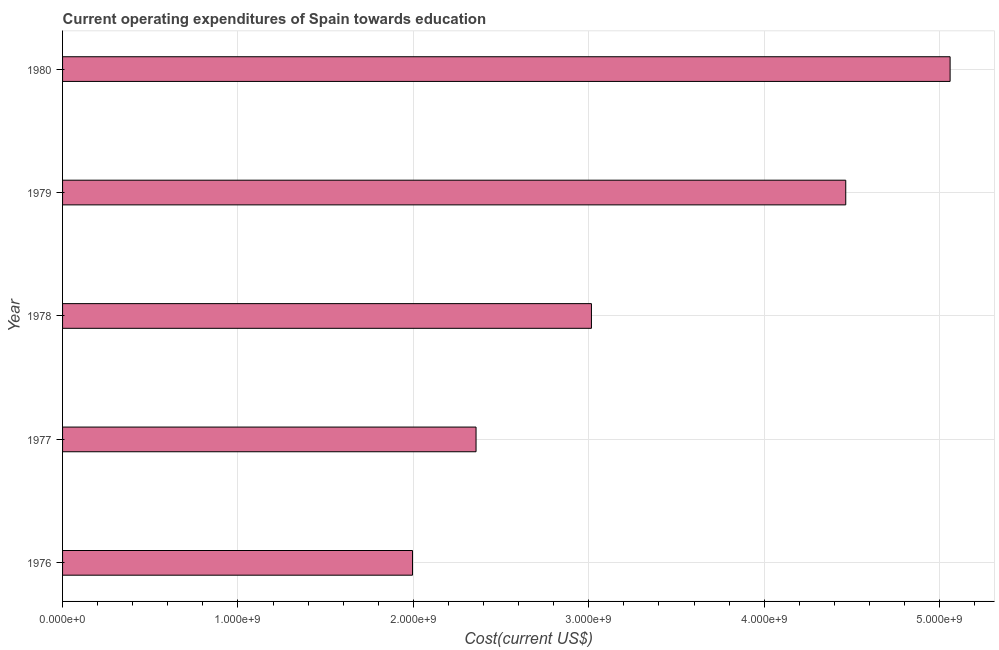Does the graph contain any zero values?
Ensure brevity in your answer.  No. Does the graph contain grids?
Give a very brief answer. Yes. What is the title of the graph?
Your answer should be very brief. Current operating expenditures of Spain towards education. What is the label or title of the X-axis?
Ensure brevity in your answer.  Cost(current US$). What is the label or title of the Y-axis?
Provide a succinct answer. Year. What is the education expenditure in 1977?
Make the answer very short. 2.36e+09. Across all years, what is the maximum education expenditure?
Give a very brief answer. 5.06e+09. Across all years, what is the minimum education expenditure?
Make the answer very short. 1.99e+09. In which year was the education expenditure maximum?
Your response must be concise. 1980. In which year was the education expenditure minimum?
Keep it short and to the point. 1976. What is the sum of the education expenditure?
Give a very brief answer. 1.69e+1. What is the difference between the education expenditure in 1978 and 1979?
Provide a short and direct response. -1.45e+09. What is the average education expenditure per year?
Your response must be concise. 3.38e+09. What is the median education expenditure?
Ensure brevity in your answer.  3.01e+09. Do a majority of the years between 1976 and 1979 (inclusive) have education expenditure greater than 3600000000 US$?
Make the answer very short. No. What is the ratio of the education expenditure in 1978 to that in 1980?
Provide a short and direct response. 0.6. Is the education expenditure in 1976 less than that in 1977?
Give a very brief answer. Yes. Is the difference between the education expenditure in 1976 and 1980 greater than the difference between any two years?
Your answer should be very brief. Yes. What is the difference between the highest and the second highest education expenditure?
Your answer should be very brief. 5.95e+08. What is the difference between the highest and the lowest education expenditure?
Keep it short and to the point. 3.06e+09. How many bars are there?
Your response must be concise. 5. Are all the bars in the graph horizontal?
Make the answer very short. Yes. How many years are there in the graph?
Your response must be concise. 5. What is the difference between two consecutive major ticks on the X-axis?
Provide a short and direct response. 1.00e+09. What is the Cost(current US$) of 1976?
Your response must be concise. 1.99e+09. What is the Cost(current US$) in 1977?
Offer a terse response. 2.36e+09. What is the Cost(current US$) of 1978?
Give a very brief answer. 3.01e+09. What is the Cost(current US$) of 1979?
Provide a short and direct response. 4.46e+09. What is the Cost(current US$) in 1980?
Provide a succinct answer. 5.06e+09. What is the difference between the Cost(current US$) in 1976 and 1977?
Provide a succinct answer. -3.62e+08. What is the difference between the Cost(current US$) in 1976 and 1978?
Offer a terse response. -1.02e+09. What is the difference between the Cost(current US$) in 1976 and 1979?
Your response must be concise. -2.47e+09. What is the difference between the Cost(current US$) in 1976 and 1980?
Give a very brief answer. -3.06e+09. What is the difference between the Cost(current US$) in 1977 and 1978?
Give a very brief answer. -6.58e+08. What is the difference between the Cost(current US$) in 1977 and 1979?
Make the answer very short. -2.11e+09. What is the difference between the Cost(current US$) in 1977 and 1980?
Give a very brief answer. -2.70e+09. What is the difference between the Cost(current US$) in 1978 and 1979?
Offer a terse response. -1.45e+09. What is the difference between the Cost(current US$) in 1978 and 1980?
Offer a very short reply. -2.04e+09. What is the difference between the Cost(current US$) in 1979 and 1980?
Provide a short and direct response. -5.95e+08. What is the ratio of the Cost(current US$) in 1976 to that in 1977?
Offer a very short reply. 0.85. What is the ratio of the Cost(current US$) in 1976 to that in 1978?
Make the answer very short. 0.66. What is the ratio of the Cost(current US$) in 1976 to that in 1979?
Offer a terse response. 0.45. What is the ratio of the Cost(current US$) in 1976 to that in 1980?
Provide a succinct answer. 0.39. What is the ratio of the Cost(current US$) in 1977 to that in 1978?
Keep it short and to the point. 0.78. What is the ratio of the Cost(current US$) in 1977 to that in 1979?
Provide a short and direct response. 0.53. What is the ratio of the Cost(current US$) in 1977 to that in 1980?
Make the answer very short. 0.47. What is the ratio of the Cost(current US$) in 1978 to that in 1979?
Your answer should be compact. 0.68. What is the ratio of the Cost(current US$) in 1978 to that in 1980?
Make the answer very short. 0.6. What is the ratio of the Cost(current US$) in 1979 to that in 1980?
Give a very brief answer. 0.88. 